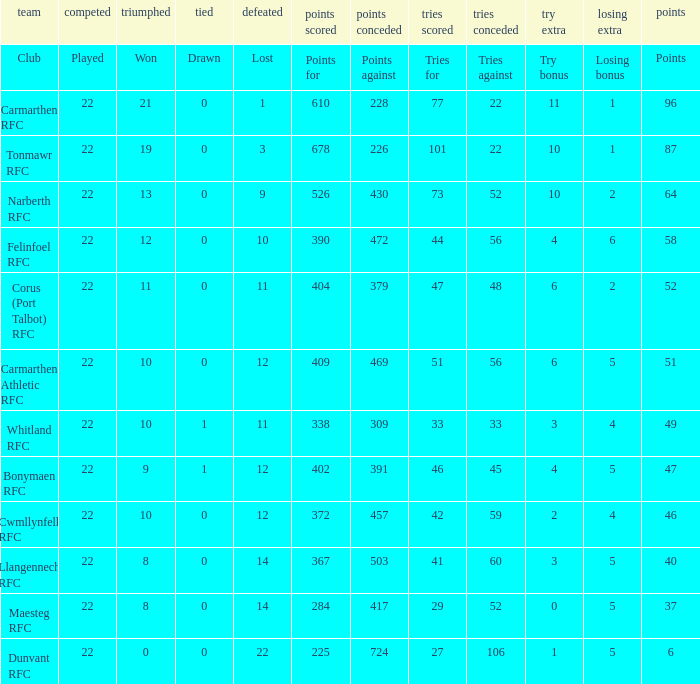Name the points against for 51 points 469.0. 